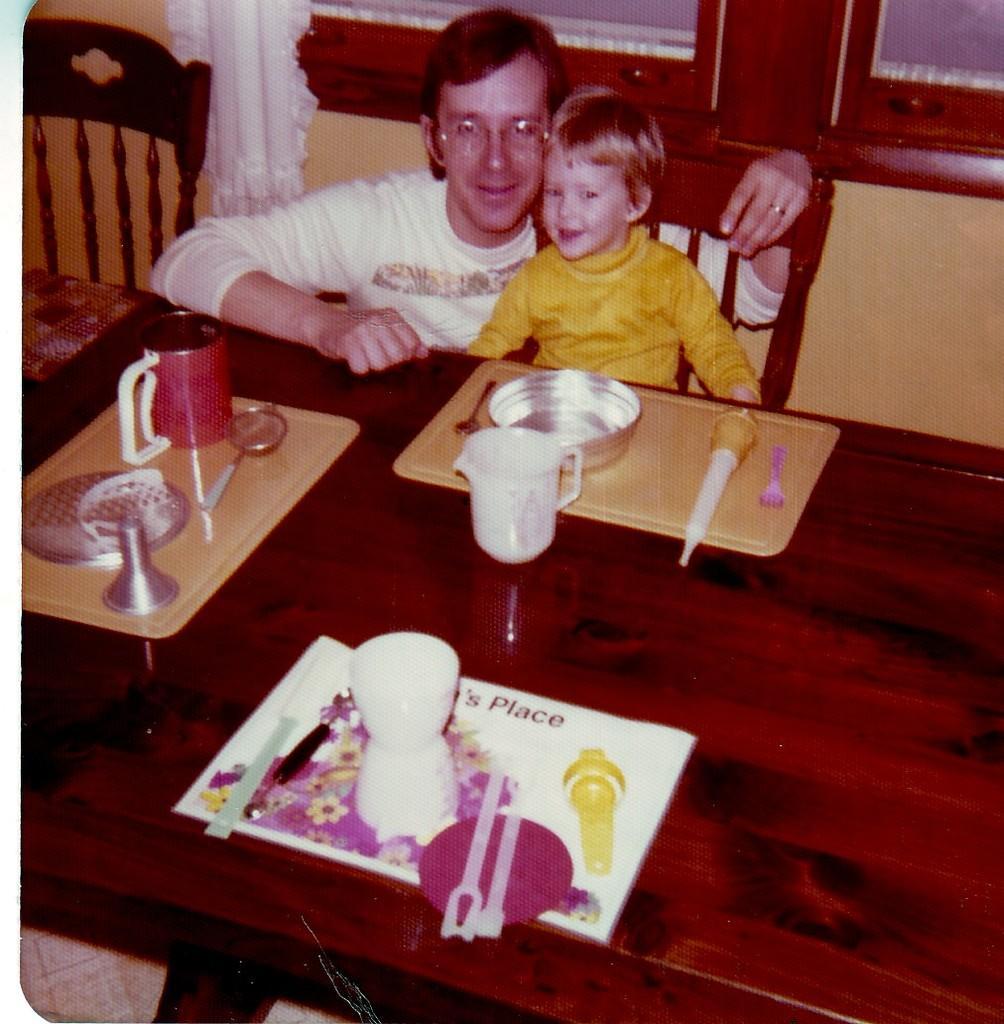Could you give a brief overview of what you see in this image? In this image, there are two persons visible. One is sitting on the chair and another is sitting beside this person and both are smiling. In the middle of the image and bottom, there is table which is brown in color, on which tray, bowl, mug, sift and knives are kept. In the background I can see a window on which white color curtain is visible and a wall is which is light yellow in color. This picture is taken inside a room. 